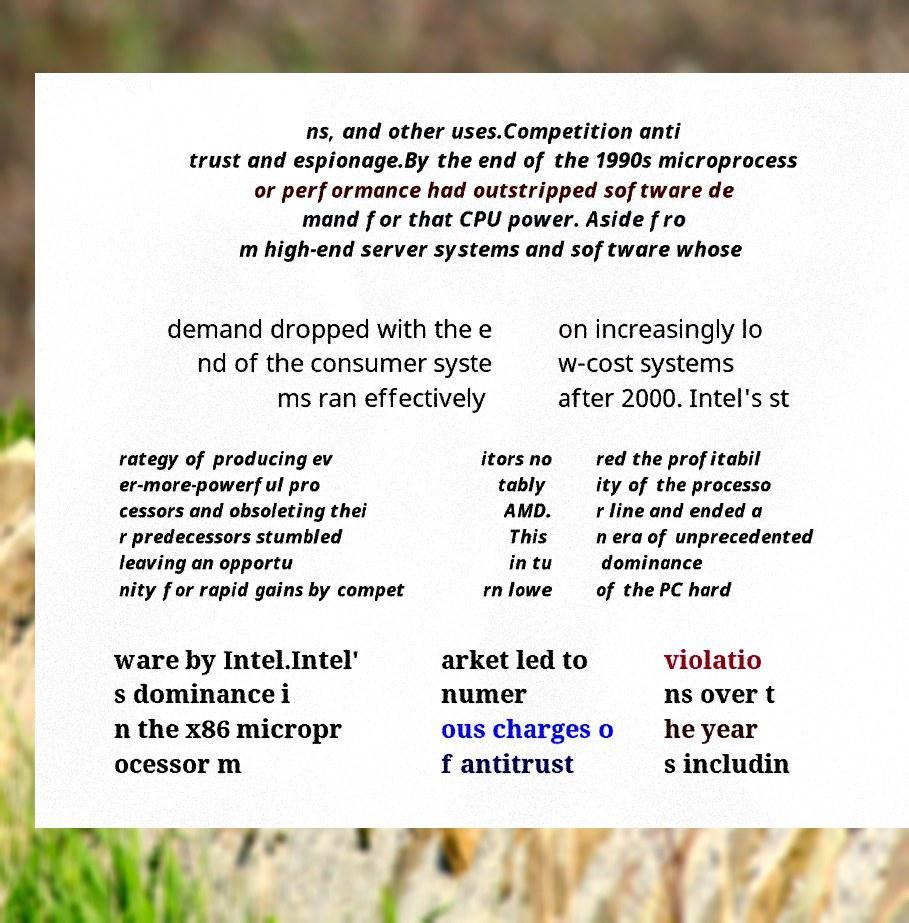There's text embedded in this image that I need extracted. Can you transcribe it verbatim? ns, and other uses.Competition anti trust and espionage.By the end of the 1990s microprocess or performance had outstripped software de mand for that CPU power. Aside fro m high-end server systems and software whose demand dropped with the e nd of the consumer syste ms ran effectively on increasingly lo w-cost systems after 2000. Intel's st rategy of producing ev er-more-powerful pro cessors and obsoleting thei r predecessors stumbled leaving an opportu nity for rapid gains by compet itors no tably AMD. This in tu rn lowe red the profitabil ity of the processo r line and ended a n era of unprecedented dominance of the PC hard ware by Intel.Intel' s dominance i n the x86 micropr ocessor m arket led to numer ous charges o f antitrust violatio ns over t he year s includin 